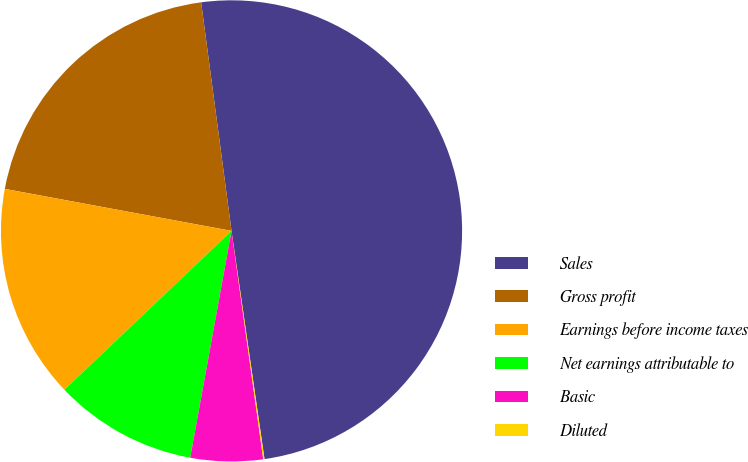<chart> <loc_0><loc_0><loc_500><loc_500><pie_chart><fcel>Sales<fcel>Gross profit<fcel>Earnings before income taxes<fcel>Net earnings attributable to<fcel>Basic<fcel>Diluted<nl><fcel>49.82%<fcel>19.98%<fcel>15.01%<fcel>10.04%<fcel>5.06%<fcel>0.09%<nl></chart> 